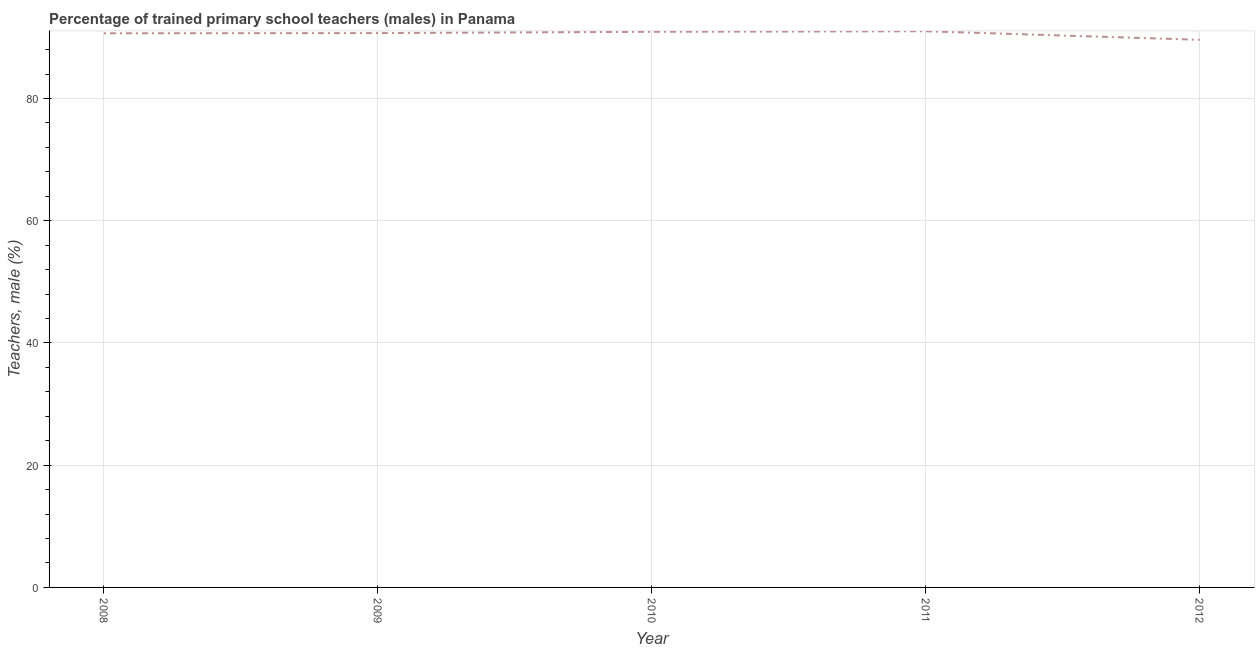What is the percentage of trained male teachers in 2010?
Offer a very short reply. 90.92. Across all years, what is the maximum percentage of trained male teachers?
Keep it short and to the point. 91.01. Across all years, what is the minimum percentage of trained male teachers?
Make the answer very short. 89.62. In which year was the percentage of trained male teachers maximum?
Provide a succinct answer. 2011. In which year was the percentage of trained male teachers minimum?
Your answer should be compact. 2012. What is the sum of the percentage of trained male teachers?
Give a very brief answer. 452.95. What is the difference between the percentage of trained male teachers in 2008 and 2010?
Provide a short and direct response. -0.24. What is the average percentage of trained male teachers per year?
Keep it short and to the point. 90.59. What is the median percentage of trained male teachers?
Offer a terse response. 90.71. In how many years, is the percentage of trained male teachers greater than 8 %?
Give a very brief answer. 5. What is the ratio of the percentage of trained male teachers in 2008 to that in 2010?
Your answer should be very brief. 1. Is the percentage of trained male teachers in 2008 less than that in 2009?
Your response must be concise. Yes. What is the difference between the highest and the second highest percentage of trained male teachers?
Offer a terse response. 0.09. Is the sum of the percentage of trained male teachers in 2009 and 2012 greater than the maximum percentage of trained male teachers across all years?
Offer a terse response. Yes. What is the difference between the highest and the lowest percentage of trained male teachers?
Offer a very short reply. 1.4. In how many years, is the percentage of trained male teachers greater than the average percentage of trained male teachers taken over all years?
Your answer should be very brief. 4. Does the percentage of trained male teachers monotonically increase over the years?
Your response must be concise. No. How many lines are there?
Give a very brief answer. 1. What is the difference between two consecutive major ticks on the Y-axis?
Provide a succinct answer. 20. What is the title of the graph?
Keep it short and to the point. Percentage of trained primary school teachers (males) in Panama. What is the label or title of the X-axis?
Give a very brief answer. Year. What is the label or title of the Y-axis?
Offer a terse response. Teachers, male (%). What is the Teachers, male (%) in 2008?
Offer a very short reply. 90.68. What is the Teachers, male (%) in 2009?
Your answer should be compact. 90.71. What is the Teachers, male (%) of 2010?
Ensure brevity in your answer.  90.92. What is the Teachers, male (%) of 2011?
Give a very brief answer. 91.01. What is the Teachers, male (%) of 2012?
Offer a very short reply. 89.62. What is the difference between the Teachers, male (%) in 2008 and 2009?
Your answer should be very brief. -0.03. What is the difference between the Teachers, male (%) in 2008 and 2010?
Make the answer very short. -0.24. What is the difference between the Teachers, male (%) in 2008 and 2011?
Offer a very short reply. -0.33. What is the difference between the Teachers, male (%) in 2008 and 2012?
Your answer should be very brief. 1.06. What is the difference between the Teachers, male (%) in 2009 and 2010?
Ensure brevity in your answer.  -0.21. What is the difference between the Teachers, male (%) in 2009 and 2011?
Offer a very short reply. -0.3. What is the difference between the Teachers, male (%) in 2009 and 2012?
Provide a succinct answer. 1.1. What is the difference between the Teachers, male (%) in 2010 and 2011?
Give a very brief answer. -0.09. What is the difference between the Teachers, male (%) in 2010 and 2012?
Your answer should be compact. 1.31. What is the difference between the Teachers, male (%) in 2011 and 2012?
Provide a succinct answer. 1.4. What is the ratio of the Teachers, male (%) in 2008 to that in 2009?
Keep it short and to the point. 1. What is the ratio of the Teachers, male (%) in 2008 to that in 2010?
Offer a terse response. 1. What is the ratio of the Teachers, male (%) in 2008 to that in 2011?
Make the answer very short. 1. What is the ratio of the Teachers, male (%) in 2009 to that in 2010?
Your answer should be compact. 1. What is the ratio of the Teachers, male (%) in 2009 to that in 2011?
Offer a terse response. 1. What is the ratio of the Teachers, male (%) in 2009 to that in 2012?
Make the answer very short. 1.01. What is the ratio of the Teachers, male (%) in 2010 to that in 2012?
Give a very brief answer. 1.01. 